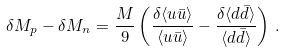<formula> <loc_0><loc_0><loc_500><loc_500>\delta M _ { p } - \delta M _ { n } = \frac { M } { 9 } \left ( \frac { \delta \langle u \bar { u } \rangle } { \langle u \bar { u } \rangle } - \frac { \delta \langle d \bar { d } \rangle } { \langle d \bar { d } \rangle } \right ) \, .</formula> 